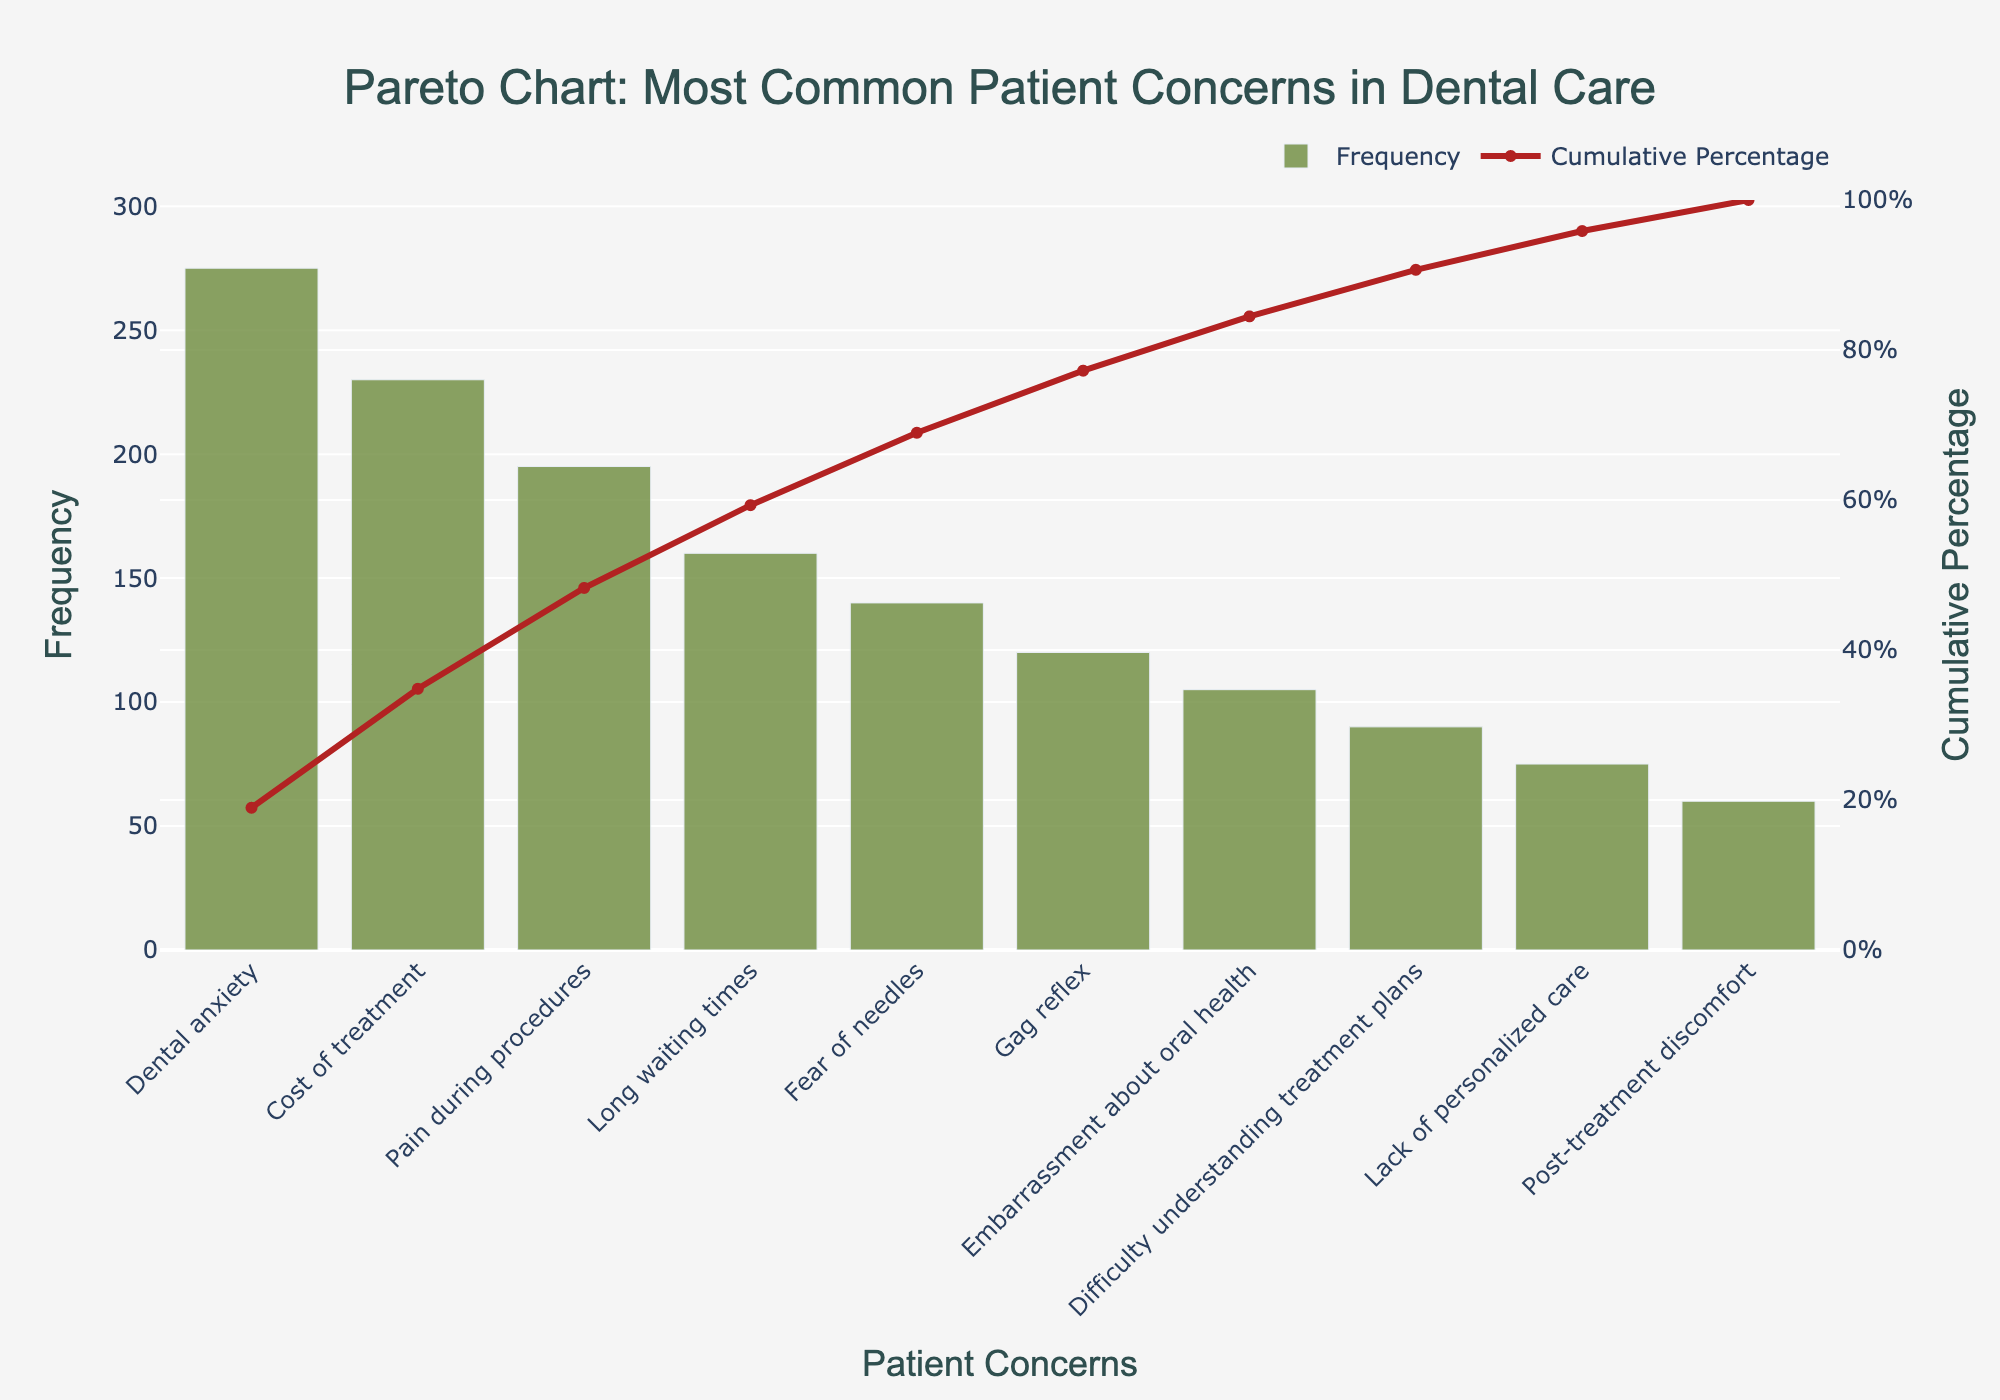What's the most common patient concern in dental care? The most common patient concern is represented by the highest bar in the chart.
Answer: Dental anxiety What's the cumulative percentage at "Cost of treatment"? The cumulative percentage at "Cost of treatment" is where the cumulative percentage line intersects the "Cost of treatment" bar.
Answer: 47.95% How many patient concerns have a frequency higher than 150? By looking at the heights of the bars and their corresponding frequencies, count the number of concerns with a frequency above 150.
Answer: 3 Which concern contributes to reaching the 80% cumulative percentage threshold? Identify the bars along the cumulative percentage line until it reaches 80%. This includes concerns up to and including "Gag reflex".
Answer: Gag reflex What is the total frequency of "Pain during procedures" and "Long waiting times"? Add the frequencies of "Pain during procedures" (195) and "Long waiting times" (160).
Answer: 355 Which concern has the least frequency, and what is the cumulative percentage at that point? The least frequent concern is identified by the shortest bar, and its cumulative percentage can be read from where the line ends at this concern.
Answer: Post-treatment discomfort, 100% How does the frequency of "Fear of needles" compare to "Gag reflex"? Compare the heights of the bars for "Fear of needles" (140) and "Gag reflex" (120).
Answer: Greater At which patient concern does the cumulative percentage first exceed 50%? Track the cumulative percentage line and identify the first concern where it crosses the 50% mark.
Answer: Pain during procedures What's the sum of the frequencies for the first four most common concerns? Add the frequencies of the first four concerns: "Dental anxiety" (275), "Cost of treatment" (230), "Pain during procedures" (195), and "Long waiting times" (160).
Answer: 860 What's the difference in frequency between "Embarrassment about oral health" and "Difficulty understanding treatment plans"? Subtract the frequency of "Difficulty understanding treatment plans" (90) from "Embarrassment about oral health" (105).
Answer: 15 